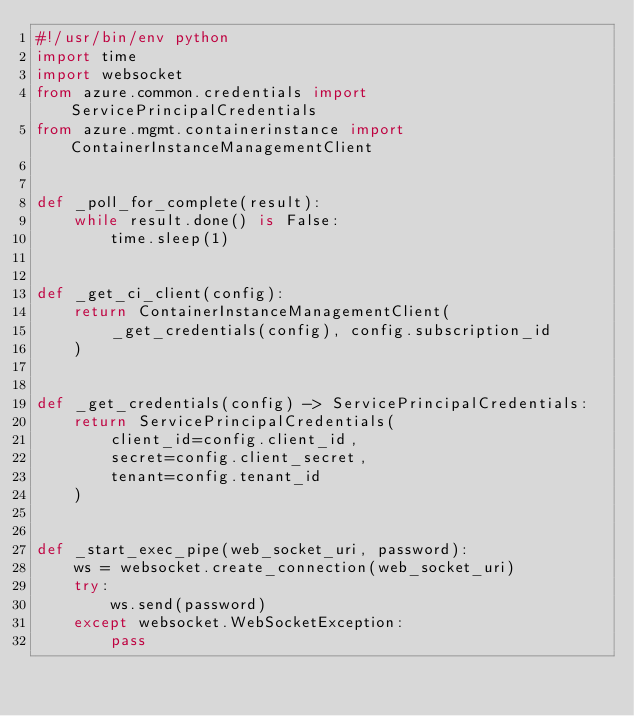<code> <loc_0><loc_0><loc_500><loc_500><_Python_>#!/usr/bin/env python
import time
import websocket
from azure.common.credentials import ServicePrincipalCredentials
from azure.mgmt.containerinstance import ContainerInstanceManagementClient


def _poll_for_complete(result):
    while result.done() is False:
        time.sleep(1)


def _get_ci_client(config):
    return ContainerInstanceManagementClient(
        _get_credentials(config), config.subscription_id
    )


def _get_credentials(config) -> ServicePrincipalCredentials:
    return ServicePrincipalCredentials(
        client_id=config.client_id,
        secret=config.client_secret,
        tenant=config.tenant_id
    )


def _start_exec_pipe(web_socket_uri, password):
    ws = websocket.create_connection(web_socket_uri)
    try:
        ws.send(password)
    except websocket.WebSocketException:
        pass
</code> 